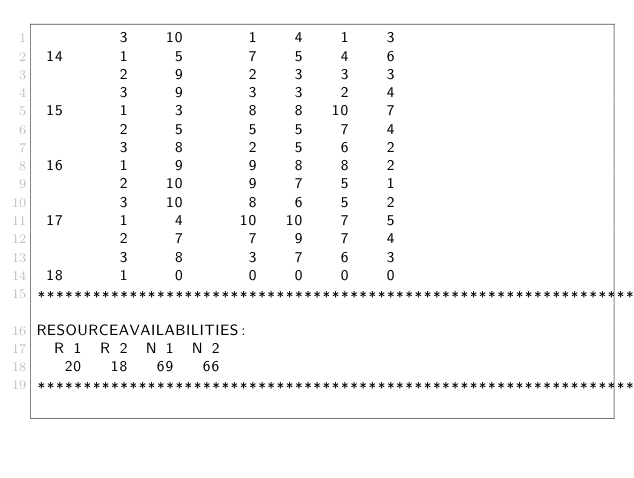<code> <loc_0><loc_0><loc_500><loc_500><_ObjectiveC_>         3    10       1    4    1    3
 14      1     5       7    5    4    6
         2     9       2    3    3    3
         3     9       3    3    2    4
 15      1     3       8    8   10    7
         2     5       5    5    7    4
         3     8       2    5    6    2
 16      1     9       9    8    8    2
         2    10       9    7    5    1
         3    10       8    6    5    2
 17      1     4      10   10    7    5
         2     7       7    9    7    4
         3     8       3    7    6    3
 18      1     0       0    0    0    0
************************************************************************
RESOURCEAVAILABILITIES:
  R 1  R 2  N 1  N 2
   20   18   69   66
************************************************************************
</code> 